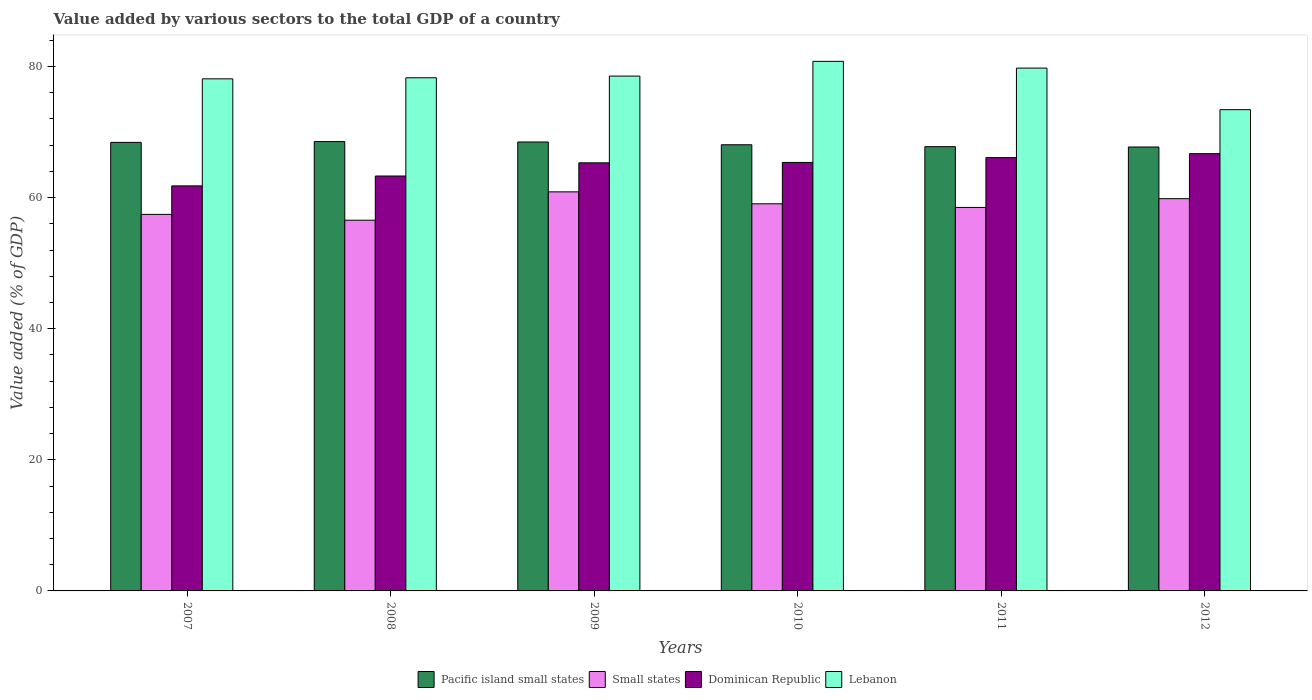Are the number of bars on each tick of the X-axis equal?
Offer a terse response. Yes. How many bars are there on the 4th tick from the left?
Give a very brief answer. 4. In how many cases, is the number of bars for a given year not equal to the number of legend labels?
Offer a very short reply. 0. What is the value added by various sectors to the total GDP in Lebanon in 2007?
Your answer should be compact. 78.11. Across all years, what is the maximum value added by various sectors to the total GDP in Small states?
Provide a succinct answer. 60.87. Across all years, what is the minimum value added by various sectors to the total GDP in Lebanon?
Offer a very short reply. 73.41. In which year was the value added by various sectors to the total GDP in Lebanon maximum?
Make the answer very short. 2010. What is the total value added by various sectors to the total GDP in Small states in the graph?
Provide a short and direct response. 352.22. What is the difference between the value added by various sectors to the total GDP in Dominican Republic in 2011 and that in 2012?
Your response must be concise. -0.6. What is the difference between the value added by various sectors to the total GDP in Pacific island small states in 2008 and the value added by various sectors to the total GDP in Lebanon in 2009?
Offer a very short reply. -9.99. What is the average value added by various sectors to the total GDP in Dominican Republic per year?
Ensure brevity in your answer.  64.75. In the year 2011, what is the difference between the value added by various sectors to the total GDP in Pacific island small states and value added by various sectors to the total GDP in Lebanon?
Ensure brevity in your answer.  -11.99. What is the ratio of the value added by various sectors to the total GDP in Small states in 2007 to that in 2011?
Provide a succinct answer. 0.98. Is the value added by various sectors to the total GDP in Lebanon in 2007 less than that in 2008?
Keep it short and to the point. Yes. What is the difference between the highest and the second highest value added by various sectors to the total GDP in Small states?
Keep it short and to the point. 1.04. What is the difference between the highest and the lowest value added by various sectors to the total GDP in Lebanon?
Offer a very short reply. 7.37. In how many years, is the value added by various sectors to the total GDP in Small states greater than the average value added by various sectors to the total GDP in Small states taken over all years?
Offer a terse response. 3. What does the 4th bar from the left in 2011 represents?
Ensure brevity in your answer.  Lebanon. What does the 1st bar from the right in 2007 represents?
Your answer should be very brief. Lebanon. Is it the case that in every year, the sum of the value added by various sectors to the total GDP in Small states and value added by various sectors to the total GDP in Lebanon is greater than the value added by various sectors to the total GDP in Pacific island small states?
Give a very brief answer. Yes. How many years are there in the graph?
Provide a short and direct response. 6. Are the values on the major ticks of Y-axis written in scientific E-notation?
Provide a succinct answer. No. Where does the legend appear in the graph?
Your response must be concise. Bottom center. How are the legend labels stacked?
Provide a short and direct response. Horizontal. What is the title of the graph?
Offer a terse response. Value added by various sectors to the total GDP of a country. Does "Grenada" appear as one of the legend labels in the graph?
Ensure brevity in your answer.  No. What is the label or title of the X-axis?
Ensure brevity in your answer.  Years. What is the label or title of the Y-axis?
Provide a short and direct response. Value added (% of GDP). What is the Value added (% of GDP) in Pacific island small states in 2007?
Offer a very short reply. 68.42. What is the Value added (% of GDP) of Small states in 2007?
Offer a terse response. 57.43. What is the Value added (% of GDP) of Dominican Republic in 2007?
Offer a terse response. 61.78. What is the Value added (% of GDP) of Lebanon in 2007?
Offer a terse response. 78.11. What is the Value added (% of GDP) in Pacific island small states in 2008?
Offer a terse response. 68.54. What is the Value added (% of GDP) in Small states in 2008?
Your answer should be compact. 56.54. What is the Value added (% of GDP) of Dominican Republic in 2008?
Give a very brief answer. 63.29. What is the Value added (% of GDP) in Lebanon in 2008?
Provide a succinct answer. 78.27. What is the Value added (% of GDP) in Pacific island small states in 2009?
Ensure brevity in your answer.  68.48. What is the Value added (% of GDP) of Small states in 2009?
Give a very brief answer. 60.87. What is the Value added (% of GDP) of Dominican Republic in 2009?
Your response must be concise. 65.3. What is the Value added (% of GDP) of Lebanon in 2009?
Your answer should be very brief. 78.53. What is the Value added (% of GDP) in Pacific island small states in 2010?
Keep it short and to the point. 68.05. What is the Value added (% of GDP) in Small states in 2010?
Provide a short and direct response. 59.05. What is the Value added (% of GDP) of Dominican Republic in 2010?
Ensure brevity in your answer.  65.36. What is the Value added (% of GDP) in Lebanon in 2010?
Give a very brief answer. 80.78. What is the Value added (% of GDP) in Pacific island small states in 2011?
Provide a succinct answer. 67.76. What is the Value added (% of GDP) in Small states in 2011?
Offer a terse response. 58.49. What is the Value added (% of GDP) of Dominican Republic in 2011?
Your answer should be very brief. 66.09. What is the Value added (% of GDP) of Lebanon in 2011?
Provide a succinct answer. 79.75. What is the Value added (% of GDP) in Pacific island small states in 2012?
Your answer should be compact. 67.71. What is the Value added (% of GDP) in Small states in 2012?
Provide a succinct answer. 59.83. What is the Value added (% of GDP) in Dominican Republic in 2012?
Your answer should be compact. 66.7. What is the Value added (% of GDP) of Lebanon in 2012?
Your answer should be compact. 73.41. Across all years, what is the maximum Value added (% of GDP) of Pacific island small states?
Offer a very short reply. 68.54. Across all years, what is the maximum Value added (% of GDP) in Small states?
Your answer should be compact. 60.87. Across all years, what is the maximum Value added (% of GDP) of Dominican Republic?
Keep it short and to the point. 66.7. Across all years, what is the maximum Value added (% of GDP) in Lebanon?
Offer a very short reply. 80.78. Across all years, what is the minimum Value added (% of GDP) of Pacific island small states?
Your answer should be compact. 67.71. Across all years, what is the minimum Value added (% of GDP) of Small states?
Your answer should be compact. 56.54. Across all years, what is the minimum Value added (% of GDP) of Dominican Republic?
Keep it short and to the point. 61.78. Across all years, what is the minimum Value added (% of GDP) of Lebanon?
Keep it short and to the point. 73.41. What is the total Value added (% of GDP) in Pacific island small states in the graph?
Provide a succinct answer. 408.96. What is the total Value added (% of GDP) in Small states in the graph?
Provide a succinct answer. 352.22. What is the total Value added (% of GDP) of Dominican Republic in the graph?
Offer a very short reply. 388.51. What is the total Value added (% of GDP) in Lebanon in the graph?
Your answer should be very brief. 468.84. What is the difference between the Value added (% of GDP) of Pacific island small states in 2007 and that in 2008?
Make the answer very short. -0.12. What is the difference between the Value added (% of GDP) in Small states in 2007 and that in 2008?
Keep it short and to the point. 0.89. What is the difference between the Value added (% of GDP) in Dominican Republic in 2007 and that in 2008?
Offer a very short reply. -1.5. What is the difference between the Value added (% of GDP) of Lebanon in 2007 and that in 2008?
Offer a terse response. -0.16. What is the difference between the Value added (% of GDP) of Pacific island small states in 2007 and that in 2009?
Your response must be concise. -0.06. What is the difference between the Value added (% of GDP) of Small states in 2007 and that in 2009?
Offer a very short reply. -3.44. What is the difference between the Value added (% of GDP) in Dominican Republic in 2007 and that in 2009?
Provide a short and direct response. -3.52. What is the difference between the Value added (% of GDP) of Lebanon in 2007 and that in 2009?
Ensure brevity in your answer.  -0.42. What is the difference between the Value added (% of GDP) of Pacific island small states in 2007 and that in 2010?
Your answer should be very brief. 0.36. What is the difference between the Value added (% of GDP) of Small states in 2007 and that in 2010?
Keep it short and to the point. -1.61. What is the difference between the Value added (% of GDP) in Dominican Republic in 2007 and that in 2010?
Offer a very short reply. -3.58. What is the difference between the Value added (% of GDP) in Lebanon in 2007 and that in 2010?
Ensure brevity in your answer.  -2.66. What is the difference between the Value added (% of GDP) of Pacific island small states in 2007 and that in 2011?
Offer a very short reply. 0.65. What is the difference between the Value added (% of GDP) of Small states in 2007 and that in 2011?
Your answer should be very brief. -1.06. What is the difference between the Value added (% of GDP) of Dominican Republic in 2007 and that in 2011?
Offer a terse response. -4.31. What is the difference between the Value added (% of GDP) of Lebanon in 2007 and that in 2011?
Your response must be concise. -1.64. What is the difference between the Value added (% of GDP) of Pacific island small states in 2007 and that in 2012?
Offer a terse response. 0.7. What is the difference between the Value added (% of GDP) in Small states in 2007 and that in 2012?
Your answer should be very brief. -2.4. What is the difference between the Value added (% of GDP) of Dominican Republic in 2007 and that in 2012?
Your response must be concise. -4.91. What is the difference between the Value added (% of GDP) of Lebanon in 2007 and that in 2012?
Give a very brief answer. 4.71. What is the difference between the Value added (% of GDP) in Pacific island small states in 2008 and that in 2009?
Provide a short and direct response. 0.06. What is the difference between the Value added (% of GDP) of Small states in 2008 and that in 2009?
Give a very brief answer. -4.33. What is the difference between the Value added (% of GDP) in Dominican Republic in 2008 and that in 2009?
Give a very brief answer. -2.01. What is the difference between the Value added (% of GDP) in Lebanon in 2008 and that in 2009?
Your answer should be compact. -0.26. What is the difference between the Value added (% of GDP) in Pacific island small states in 2008 and that in 2010?
Keep it short and to the point. 0.49. What is the difference between the Value added (% of GDP) of Small states in 2008 and that in 2010?
Provide a short and direct response. -2.5. What is the difference between the Value added (% of GDP) in Dominican Republic in 2008 and that in 2010?
Your answer should be very brief. -2.07. What is the difference between the Value added (% of GDP) in Lebanon in 2008 and that in 2010?
Provide a short and direct response. -2.51. What is the difference between the Value added (% of GDP) of Pacific island small states in 2008 and that in 2011?
Your response must be concise. 0.78. What is the difference between the Value added (% of GDP) in Small states in 2008 and that in 2011?
Provide a short and direct response. -1.95. What is the difference between the Value added (% of GDP) of Dominican Republic in 2008 and that in 2011?
Keep it short and to the point. -2.81. What is the difference between the Value added (% of GDP) in Lebanon in 2008 and that in 2011?
Give a very brief answer. -1.48. What is the difference between the Value added (% of GDP) of Pacific island small states in 2008 and that in 2012?
Your answer should be very brief. 0.83. What is the difference between the Value added (% of GDP) in Small states in 2008 and that in 2012?
Ensure brevity in your answer.  -3.29. What is the difference between the Value added (% of GDP) of Dominican Republic in 2008 and that in 2012?
Ensure brevity in your answer.  -3.41. What is the difference between the Value added (% of GDP) of Lebanon in 2008 and that in 2012?
Give a very brief answer. 4.86. What is the difference between the Value added (% of GDP) of Pacific island small states in 2009 and that in 2010?
Offer a very short reply. 0.42. What is the difference between the Value added (% of GDP) in Small states in 2009 and that in 2010?
Your response must be concise. 1.82. What is the difference between the Value added (% of GDP) in Dominican Republic in 2009 and that in 2010?
Your answer should be compact. -0.06. What is the difference between the Value added (% of GDP) of Lebanon in 2009 and that in 2010?
Ensure brevity in your answer.  -2.25. What is the difference between the Value added (% of GDP) of Pacific island small states in 2009 and that in 2011?
Provide a succinct answer. 0.72. What is the difference between the Value added (% of GDP) in Small states in 2009 and that in 2011?
Your answer should be compact. 2.38. What is the difference between the Value added (% of GDP) in Dominican Republic in 2009 and that in 2011?
Give a very brief answer. -0.79. What is the difference between the Value added (% of GDP) of Lebanon in 2009 and that in 2011?
Offer a very short reply. -1.22. What is the difference between the Value added (% of GDP) of Pacific island small states in 2009 and that in 2012?
Offer a very short reply. 0.76. What is the difference between the Value added (% of GDP) of Small states in 2009 and that in 2012?
Provide a succinct answer. 1.04. What is the difference between the Value added (% of GDP) in Dominican Republic in 2009 and that in 2012?
Your answer should be compact. -1.4. What is the difference between the Value added (% of GDP) in Lebanon in 2009 and that in 2012?
Your answer should be compact. 5.12. What is the difference between the Value added (% of GDP) in Pacific island small states in 2010 and that in 2011?
Your answer should be compact. 0.29. What is the difference between the Value added (% of GDP) of Small states in 2010 and that in 2011?
Keep it short and to the point. 0.55. What is the difference between the Value added (% of GDP) of Dominican Republic in 2010 and that in 2011?
Your answer should be very brief. -0.73. What is the difference between the Value added (% of GDP) of Lebanon in 2010 and that in 2011?
Ensure brevity in your answer.  1.03. What is the difference between the Value added (% of GDP) of Pacific island small states in 2010 and that in 2012?
Ensure brevity in your answer.  0.34. What is the difference between the Value added (% of GDP) of Small states in 2010 and that in 2012?
Provide a succinct answer. -0.78. What is the difference between the Value added (% of GDP) of Dominican Republic in 2010 and that in 2012?
Your answer should be compact. -1.34. What is the difference between the Value added (% of GDP) in Lebanon in 2010 and that in 2012?
Your answer should be compact. 7.37. What is the difference between the Value added (% of GDP) of Pacific island small states in 2011 and that in 2012?
Make the answer very short. 0.05. What is the difference between the Value added (% of GDP) in Small states in 2011 and that in 2012?
Offer a terse response. -1.34. What is the difference between the Value added (% of GDP) of Dominican Republic in 2011 and that in 2012?
Your answer should be very brief. -0.6. What is the difference between the Value added (% of GDP) of Lebanon in 2011 and that in 2012?
Ensure brevity in your answer.  6.34. What is the difference between the Value added (% of GDP) in Pacific island small states in 2007 and the Value added (% of GDP) in Small states in 2008?
Give a very brief answer. 11.87. What is the difference between the Value added (% of GDP) of Pacific island small states in 2007 and the Value added (% of GDP) of Dominican Republic in 2008?
Make the answer very short. 5.13. What is the difference between the Value added (% of GDP) of Pacific island small states in 2007 and the Value added (% of GDP) of Lebanon in 2008?
Your answer should be very brief. -9.85. What is the difference between the Value added (% of GDP) of Small states in 2007 and the Value added (% of GDP) of Dominican Republic in 2008?
Your answer should be compact. -5.85. What is the difference between the Value added (% of GDP) in Small states in 2007 and the Value added (% of GDP) in Lebanon in 2008?
Your answer should be compact. -20.84. What is the difference between the Value added (% of GDP) of Dominican Republic in 2007 and the Value added (% of GDP) of Lebanon in 2008?
Give a very brief answer. -16.49. What is the difference between the Value added (% of GDP) of Pacific island small states in 2007 and the Value added (% of GDP) of Small states in 2009?
Your response must be concise. 7.55. What is the difference between the Value added (% of GDP) of Pacific island small states in 2007 and the Value added (% of GDP) of Dominican Republic in 2009?
Offer a very short reply. 3.12. What is the difference between the Value added (% of GDP) in Pacific island small states in 2007 and the Value added (% of GDP) in Lebanon in 2009?
Your answer should be very brief. -10.11. What is the difference between the Value added (% of GDP) in Small states in 2007 and the Value added (% of GDP) in Dominican Republic in 2009?
Keep it short and to the point. -7.86. What is the difference between the Value added (% of GDP) of Small states in 2007 and the Value added (% of GDP) of Lebanon in 2009?
Your response must be concise. -21.1. What is the difference between the Value added (% of GDP) of Dominican Republic in 2007 and the Value added (% of GDP) of Lebanon in 2009?
Your answer should be compact. -16.75. What is the difference between the Value added (% of GDP) in Pacific island small states in 2007 and the Value added (% of GDP) in Small states in 2010?
Make the answer very short. 9.37. What is the difference between the Value added (% of GDP) in Pacific island small states in 2007 and the Value added (% of GDP) in Dominican Republic in 2010?
Offer a very short reply. 3.06. What is the difference between the Value added (% of GDP) of Pacific island small states in 2007 and the Value added (% of GDP) of Lebanon in 2010?
Offer a very short reply. -12.36. What is the difference between the Value added (% of GDP) of Small states in 2007 and the Value added (% of GDP) of Dominican Republic in 2010?
Keep it short and to the point. -7.92. What is the difference between the Value added (% of GDP) in Small states in 2007 and the Value added (% of GDP) in Lebanon in 2010?
Your answer should be very brief. -23.34. What is the difference between the Value added (% of GDP) of Dominican Republic in 2007 and the Value added (% of GDP) of Lebanon in 2010?
Keep it short and to the point. -18.99. What is the difference between the Value added (% of GDP) in Pacific island small states in 2007 and the Value added (% of GDP) in Small states in 2011?
Provide a short and direct response. 9.92. What is the difference between the Value added (% of GDP) in Pacific island small states in 2007 and the Value added (% of GDP) in Dominican Republic in 2011?
Provide a short and direct response. 2.32. What is the difference between the Value added (% of GDP) in Pacific island small states in 2007 and the Value added (% of GDP) in Lebanon in 2011?
Your answer should be compact. -11.33. What is the difference between the Value added (% of GDP) of Small states in 2007 and the Value added (% of GDP) of Dominican Republic in 2011?
Make the answer very short. -8.66. What is the difference between the Value added (% of GDP) in Small states in 2007 and the Value added (% of GDP) in Lebanon in 2011?
Offer a terse response. -22.32. What is the difference between the Value added (% of GDP) of Dominican Republic in 2007 and the Value added (% of GDP) of Lebanon in 2011?
Your answer should be very brief. -17.97. What is the difference between the Value added (% of GDP) of Pacific island small states in 2007 and the Value added (% of GDP) of Small states in 2012?
Provide a succinct answer. 8.59. What is the difference between the Value added (% of GDP) in Pacific island small states in 2007 and the Value added (% of GDP) in Dominican Republic in 2012?
Your answer should be very brief. 1.72. What is the difference between the Value added (% of GDP) in Pacific island small states in 2007 and the Value added (% of GDP) in Lebanon in 2012?
Make the answer very short. -4.99. What is the difference between the Value added (% of GDP) in Small states in 2007 and the Value added (% of GDP) in Dominican Republic in 2012?
Keep it short and to the point. -9.26. What is the difference between the Value added (% of GDP) in Small states in 2007 and the Value added (% of GDP) in Lebanon in 2012?
Your answer should be very brief. -15.97. What is the difference between the Value added (% of GDP) of Dominican Republic in 2007 and the Value added (% of GDP) of Lebanon in 2012?
Your answer should be very brief. -11.62. What is the difference between the Value added (% of GDP) in Pacific island small states in 2008 and the Value added (% of GDP) in Small states in 2009?
Your answer should be very brief. 7.67. What is the difference between the Value added (% of GDP) of Pacific island small states in 2008 and the Value added (% of GDP) of Dominican Republic in 2009?
Your response must be concise. 3.24. What is the difference between the Value added (% of GDP) of Pacific island small states in 2008 and the Value added (% of GDP) of Lebanon in 2009?
Keep it short and to the point. -9.99. What is the difference between the Value added (% of GDP) of Small states in 2008 and the Value added (% of GDP) of Dominican Republic in 2009?
Provide a succinct answer. -8.75. What is the difference between the Value added (% of GDP) of Small states in 2008 and the Value added (% of GDP) of Lebanon in 2009?
Keep it short and to the point. -21.99. What is the difference between the Value added (% of GDP) in Dominican Republic in 2008 and the Value added (% of GDP) in Lebanon in 2009?
Keep it short and to the point. -15.24. What is the difference between the Value added (% of GDP) in Pacific island small states in 2008 and the Value added (% of GDP) in Small states in 2010?
Keep it short and to the point. 9.49. What is the difference between the Value added (% of GDP) of Pacific island small states in 2008 and the Value added (% of GDP) of Dominican Republic in 2010?
Your answer should be compact. 3.18. What is the difference between the Value added (% of GDP) of Pacific island small states in 2008 and the Value added (% of GDP) of Lebanon in 2010?
Give a very brief answer. -12.24. What is the difference between the Value added (% of GDP) in Small states in 2008 and the Value added (% of GDP) in Dominican Republic in 2010?
Keep it short and to the point. -8.81. What is the difference between the Value added (% of GDP) of Small states in 2008 and the Value added (% of GDP) of Lebanon in 2010?
Provide a short and direct response. -24.23. What is the difference between the Value added (% of GDP) of Dominican Republic in 2008 and the Value added (% of GDP) of Lebanon in 2010?
Give a very brief answer. -17.49. What is the difference between the Value added (% of GDP) in Pacific island small states in 2008 and the Value added (% of GDP) in Small states in 2011?
Keep it short and to the point. 10.04. What is the difference between the Value added (% of GDP) in Pacific island small states in 2008 and the Value added (% of GDP) in Dominican Republic in 2011?
Offer a terse response. 2.45. What is the difference between the Value added (% of GDP) in Pacific island small states in 2008 and the Value added (% of GDP) in Lebanon in 2011?
Your response must be concise. -11.21. What is the difference between the Value added (% of GDP) of Small states in 2008 and the Value added (% of GDP) of Dominican Republic in 2011?
Provide a short and direct response. -9.55. What is the difference between the Value added (% of GDP) in Small states in 2008 and the Value added (% of GDP) in Lebanon in 2011?
Give a very brief answer. -23.21. What is the difference between the Value added (% of GDP) in Dominican Republic in 2008 and the Value added (% of GDP) in Lebanon in 2011?
Keep it short and to the point. -16.46. What is the difference between the Value added (% of GDP) of Pacific island small states in 2008 and the Value added (% of GDP) of Small states in 2012?
Make the answer very short. 8.71. What is the difference between the Value added (% of GDP) of Pacific island small states in 2008 and the Value added (% of GDP) of Dominican Republic in 2012?
Provide a succinct answer. 1.84. What is the difference between the Value added (% of GDP) in Pacific island small states in 2008 and the Value added (% of GDP) in Lebanon in 2012?
Your response must be concise. -4.87. What is the difference between the Value added (% of GDP) in Small states in 2008 and the Value added (% of GDP) in Dominican Republic in 2012?
Your answer should be compact. -10.15. What is the difference between the Value added (% of GDP) of Small states in 2008 and the Value added (% of GDP) of Lebanon in 2012?
Make the answer very short. -16.86. What is the difference between the Value added (% of GDP) of Dominican Republic in 2008 and the Value added (% of GDP) of Lebanon in 2012?
Keep it short and to the point. -10.12. What is the difference between the Value added (% of GDP) in Pacific island small states in 2009 and the Value added (% of GDP) in Small states in 2010?
Offer a very short reply. 9.43. What is the difference between the Value added (% of GDP) in Pacific island small states in 2009 and the Value added (% of GDP) in Dominican Republic in 2010?
Provide a succinct answer. 3.12. What is the difference between the Value added (% of GDP) in Pacific island small states in 2009 and the Value added (% of GDP) in Lebanon in 2010?
Keep it short and to the point. -12.3. What is the difference between the Value added (% of GDP) of Small states in 2009 and the Value added (% of GDP) of Dominican Republic in 2010?
Provide a succinct answer. -4.49. What is the difference between the Value added (% of GDP) of Small states in 2009 and the Value added (% of GDP) of Lebanon in 2010?
Keep it short and to the point. -19.91. What is the difference between the Value added (% of GDP) in Dominican Republic in 2009 and the Value added (% of GDP) in Lebanon in 2010?
Give a very brief answer. -15.48. What is the difference between the Value added (% of GDP) in Pacific island small states in 2009 and the Value added (% of GDP) in Small states in 2011?
Ensure brevity in your answer.  9.98. What is the difference between the Value added (% of GDP) in Pacific island small states in 2009 and the Value added (% of GDP) in Dominican Republic in 2011?
Keep it short and to the point. 2.39. What is the difference between the Value added (% of GDP) of Pacific island small states in 2009 and the Value added (% of GDP) of Lebanon in 2011?
Ensure brevity in your answer.  -11.27. What is the difference between the Value added (% of GDP) of Small states in 2009 and the Value added (% of GDP) of Dominican Republic in 2011?
Offer a very short reply. -5.22. What is the difference between the Value added (% of GDP) in Small states in 2009 and the Value added (% of GDP) in Lebanon in 2011?
Offer a terse response. -18.88. What is the difference between the Value added (% of GDP) of Dominican Republic in 2009 and the Value added (% of GDP) of Lebanon in 2011?
Give a very brief answer. -14.45. What is the difference between the Value added (% of GDP) in Pacific island small states in 2009 and the Value added (% of GDP) in Small states in 2012?
Offer a terse response. 8.65. What is the difference between the Value added (% of GDP) of Pacific island small states in 2009 and the Value added (% of GDP) of Dominican Republic in 2012?
Make the answer very short. 1.78. What is the difference between the Value added (% of GDP) of Pacific island small states in 2009 and the Value added (% of GDP) of Lebanon in 2012?
Offer a terse response. -4.93. What is the difference between the Value added (% of GDP) of Small states in 2009 and the Value added (% of GDP) of Dominican Republic in 2012?
Offer a terse response. -5.83. What is the difference between the Value added (% of GDP) in Small states in 2009 and the Value added (% of GDP) in Lebanon in 2012?
Your answer should be compact. -12.54. What is the difference between the Value added (% of GDP) of Dominican Republic in 2009 and the Value added (% of GDP) of Lebanon in 2012?
Provide a short and direct response. -8.11. What is the difference between the Value added (% of GDP) in Pacific island small states in 2010 and the Value added (% of GDP) in Small states in 2011?
Offer a very short reply. 9.56. What is the difference between the Value added (% of GDP) of Pacific island small states in 2010 and the Value added (% of GDP) of Dominican Republic in 2011?
Provide a succinct answer. 1.96. What is the difference between the Value added (% of GDP) in Pacific island small states in 2010 and the Value added (% of GDP) in Lebanon in 2011?
Provide a succinct answer. -11.7. What is the difference between the Value added (% of GDP) of Small states in 2010 and the Value added (% of GDP) of Dominican Republic in 2011?
Give a very brief answer. -7.05. What is the difference between the Value added (% of GDP) in Small states in 2010 and the Value added (% of GDP) in Lebanon in 2011?
Offer a terse response. -20.7. What is the difference between the Value added (% of GDP) in Dominican Republic in 2010 and the Value added (% of GDP) in Lebanon in 2011?
Your answer should be compact. -14.39. What is the difference between the Value added (% of GDP) of Pacific island small states in 2010 and the Value added (% of GDP) of Small states in 2012?
Your answer should be very brief. 8.22. What is the difference between the Value added (% of GDP) of Pacific island small states in 2010 and the Value added (% of GDP) of Dominican Republic in 2012?
Keep it short and to the point. 1.36. What is the difference between the Value added (% of GDP) of Pacific island small states in 2010 and the Value added (% of GDP) of Lebanon in 2012?
Give a very brief answer. -5.35. What is the difference between the Value added (% of GDP) in Small states in 2010 and the Value added (% of GDP) in Dominican Republic in 2012?
Provide a succinct answer. -7.65. What is the difference between the Value added (% of GDP) of Small states in 2010 and the Value added (% of GDP) of Lebanon in 2012?
Offer a terse response. -14.36. What is the difference between the Value added (% of GDP) of Dominican Republic in 2010 and the Value added (% of GDP) of Lebanon in 2012?
Your answer should be very brief. -8.05. What is the difference between the Value added (% of GDP) of Pacific island small states in 2011 and the Value added (% of GDP) of Small states in 2012?
Provide a succinct answer. 7.93. What is the difference between the Value added (% of GDP) of Pacific island small states in 2011 and the Value added (% of GDP) of Dominican Republic in 2012?
Make the answer very short. 1.07. What is the difference between the Value added (% of GDP) in Pacific island small states in 2011 and the Value added (% of GDP) in Lebanon in 2012?
Make the answer very short. -5.64. What is the difference between the Value added (% of GDP) in Small states in 2011 and the Value added (% of GDP) in Dominican Republic in 2012?
Provide a short and direct response. -8.2. What is the difference between the Value added (% of GDP) in Small states in 2011 and the Value added (% of GDP) in Lebanon in 2012?
Offer a very short reply. -14.91. What is the difference between the Value added (% of GDP) in Dominican Republic in 2011 and the Value added (% of GDP) in Lebanon in 2012?
Provide a succinct answer. -7.31. What is the average Value added (% of GDP) of Pacific island small states per year?
Make the answer very short. 68.16. What is the average Value added (% of GDP) of Small states per year?
Provide a short and direct response. 58.7. What is the average Value added (% of GDP) in Dominican Republic per year?
Offer a very short reply. 64.75. What is the average Value added (% of GDP) of Lebanon per year?
Provide a succinct answer. 78.14. In the year 2007, what is the difference between the Value added (% of GDP) of Pacific island small states and Value added (% of GDP) of Small states?
Make the answer very short. 10.98. In the year 2007, what is the difference between the Value added (% of GDP) in Pacific island small states and Value added (% of GDP) in Dominican Republic?
Provide a short and direct response. 6.64. In the year 2007, what is the difference between the Value added (% of GDP) in Pacific island small states and Value added (% of GDP) in Lebanon?
Make the answer very short. -9.69. In the year 2007, what is the difference between the Value added (% of GDP) of Small states and Value added (% of GDP) of Dominican Republic?
Make the answer very short. -4.35. In the year 2007, what is the difference between the Value added (% of GDP) of Small states and Value added (% of GDP) of Lebanon?
Your answer should be compact. -20.68. In the year 2007, what is the difference between the Value added (% of GDP) of Dominican Republic and Value added (% of GDP) of Lebanon?
Provide a succinct answer. -16.33. In the year 2008, what is the difference between the Value added (% of GDP) in Pacific island small states and Value added (% of GDP) in Small states?
Your answer should be compact. 12. In the year 2008, what is the difference between the Value added (% of GDP) of Pacific island small states and Value added (% of GDP) of Dominican Republic?
Provide a short and direct response. 5.25. In the year 2008, what is the difference between the Value added (% of GDP) of Pacific island small states and Value added (% of GDP) of Lebanon?
Offer a terse response. -9.73. In the year 2008, what is the difference between the Value added (% of GDP) in Small states and Value added (% of GDP) in Dominican Republic?
Ensure brevity in your answer.  -6.74. In the year 2008, what is the difference between the Value added (% of GDP) of Small states and Value added (% of GDP) of Lebanon?
Your answer should be very brief. -21.73. In the year 2008, what is the difference between the Value added (% of GDP) in Dominican Republic and Value added (% of GDP) in Lebanon?
Offer a very short reply. -14.98. In the year 2009, what is the difference between the Value added (% of GDP) of Pacific island small states and Value added (% of GDP) of Small states?
Your response must be concise. 7.61. In the year 2009, what is the difference between the Value added (% of GDP) of Pacific island small states and Value added (% of GDP) of Dominican Republic?
Make the answer very short. 3.18. In the year 2009, what is the difference between the Value added (% of GDP) in Pacific island small states and Value added (% of GDP) in Lebanon?
Give a very brief answer. -10.05. In the year 2009, what is the difference between the Value added (% of GDP) of Small states and Value added (% of GDP) of Dominican Republic?
Give a very brief answer. -4.43. In the year 2009, what is the difference between the Value added (% of GDP) of Small states and Value added (% of GDP) of Lebanon?
Make the answer very short. -17.66. In the year 2009, what is the difference between the Value added (% of GDP) in Dominican Republic and Value added (% of GDP) in Lebanon?
Offer a terse response. -13.23. In the year 2010, what is the difference between the Value added (% of GDP) of Pacific island small states and Value added (% of GDP) of Small states?
Provide a succinct answer. 9.01. In the year 2010, what is the difference between the Value added (% of GDP) in Pacific island small states and Value added (% of GDP) in Dominican Republic?
Offer a terse response. 2.7. In the year 2010, what is the difference between the Value added (% of GDP) of Pacific island small states and Value added (% of GDP) of Lebanon?
Offer a terse response. -12.72. In the year 2010, what is the difference between the Value added (% of GDP) in Small states and Value added (% of GDP) in Dominican Republic?
Give a very brief answer. -6.31. In the year 2010, what is the difference between the Value added (% of GDP) in Small states and Value added (% of GDP) in Lebanon?
Give a very brief answer. -21.73. In the year 2010, what is the difference between the Value added (% of GDP) of Dominican Republic and Value added (% of GDP) of Lebanon?
Ensure brevity in your answer.  -15.42. In the year 2011, what is the difference between the Value added (% of GDP) of Pacific island small states and Value added (% of GDP) of Small states?
Provide a succinct answer. 9.27. In the year 2011, what is the difference between the Value added (% of GDP) in Pacific island small states and Value added (% of GDP) in Dominican Republic?
Keep it short and to the point. 1.67. In the year 2011, what is the difference between the Value added (% of GDP) in Pacific island small states and Value added (% of GDP) in Lebanon?
Keep it short and to the point. -11.99. In the year 2011, what is the difference between the Value added (% of GDP) in Small states and Value added (% of GDP) in Dominican Republic?
Provide a short and direct response. -7.6. In the year 2011, what is the difference between the Value added (% of GDP) of Small states and Value added (% of GDP) of Lebanon?
Give a very brief answer. -21.25. In the year 2011, what is the difference between the Value added (% of GDP) in Dominican Republic and Value added (% of GDP) in Lebanon?
Keep it short and to the point. -13.66. In the year 2012, what is the difference between the Value added (% of GDP) in Pacific island small states and Value added (% of GDP) in Small states?
Keep it short and to the point. 7.88. In the year 2012, what is the difference between the Value added (% of GDP) of Pacific island small states and Value added (% of GDP) of Dominican Republic?
Your answer should be compact. 1.02. In the year 2012, what is the difference between the Value added (% of GDP) in Pacific island small states and Value added (% of GDP) in Lebanon?
Offer a terse response. -5.69. In the year 2012, what is the difference between the Value added (% of GDP) of Small states and Value added (% of GDP) of Dominican Republic?
Ensure brevity in your answer.  -6.87. In the year 2012, what is the difference between the Value added (% of GDP) of Small states and Value added (% of GDP) of Lebanon?
Ensure brevity in your answer.  -13.57. In the year 2012, what is the difference between the Value added (% of GDP) of Dominican Republic and Value added (% of GDP) of Lebanon?
Offer a very short reply. -6.71. What is the ratio of the Value added (% of GDP) in Small states in 2007 to that in 2008?
Provide a short and direct response. 1.02. What is the ratio of the Value added (% of GDP) in Dominican Republic in 2007 to that in 2008?
Your answer should be very brief. 0.98. What is the ratio of the Value added (% of GDP) in Lebanon in 2007 to that in 2008?
Your answer should be compact. 1. What is the ratio of the Value added (% of GDP) in Small states in 2007 to that in 2009?
Your response must be concise. 0.94. What is the ratio of the Value added (% of GDP) in Dominican Republic in 2007 to that in 2009?
Provide a succinct answer. 0.95. What is the ratio of the Value added (% of GDP) of Pacific island small states in 2007 to that in 2010?
Ensure brevity in your answer.  1.01. What is the ratio of the Value added (% of GDP) of Small states in 2007 to that in 2010?
Offer a very short reply. 0.97. What is the ratio of the Value added (% of GDP) of Dominican Republic in 2007 to that in 2010?
Give a very brief answer. 0.95. What is the ratio of the Value added (% of GDP) of Pacific island small states in 2007 to that in 2011?
Make the answer very short. 1.01. What is the ratio of the Value added (% of GDP) in Small states in 2007 to that in 2011?
Your response must be concise. 0.98. What is the ratio of the Value added (% of GDP) in Dominican Republic in 2007 to that in 2011?
Your answer should be very brief. 0.93. What is the ratio of the Value added (% of GDP) in Lebanon in 2007 to that in 2011?
Offer a very short reply. 0.98. What is the ratio of the Value added (% of GDP) of Pacific island small states in 2007 to that in 2012?
Make the answer very short. 1.01. What is the ratio of the Value added (% of GDP) in Small states in 2007 to that in 2012?
Make the answer very short. 0.96. What is the ratio of the Value added (% of GDP) of Dominican Republic in 2007 to that in 2012?
Provide a short and direct response. 0.93. What is the ratio of the Value added (% of GDP) in Lebanon in 2007 to that in 2012?
Ensure brevity in your answer.  1.06. What is the ratio of the Value added (% of GDP) in Pacific island small states in 2008 to that in 2009?
Your answer should be compact. 1. What is the ratio of the Value added (% of GDP) in Small states in 2008 to that in 2009?
Provide a succinct answer. 0.93. What is the ratio of the Value added (% of GDP) in Dominican Republic in 2008 to that in 2009?
Your response must be concise. 0.97. What is the ratio of the Value added (% of GDP) in Lebanon in 2008 to that in 2009?
Provide a short and direct response. 1. What is the ratio of the Value added (% of GDP) in Pacific island small states in 2008 to that in 2010?
Give a very brief answer. 1.01. What is the ratio of the Value added (% of GDP) of Small states in 2008 to that in 2010?
Offer a terse response. 0.96. What is the ratio of the Value added (% of GDP) of Dominican Republic in 2008 to that in 2010?
Your answer should be very brief. 0.97. What is the ratio of the Value added (% of GDP) of Lebanon in 2008 to that in 2010?
Your answer should be compact. 0.97. What is the ratio of the Value added (% of GDP) in Pacific island small states in 2008 to that in 2011?
Your answer should be very brief. 1.01. What is the ratio of the Value added (% of GDP) of Small states in 2008 to that in 2011?
Provide a succinct answer. 0.97. What is the ratio of the Value added (% of GDP) in Dominican Republic in 2008 to that in 2011?
Give a very brief answer. 0.96. What is the ratio of the Value added (% of GDP) in Lebanon in 2008 to that in 2011?
Your response must be concise. 0.98. What is the ratio of the Value added (% of GDP) in Pacific island small states in 2008 to that in 2012?
Make the answer very short. 1.01. What is the ratio of the Value added (% of GDP) in Small states in 2008 to that in 2012?
Provide a short and direct response. 0.95. What is the ratio of the Value added (% of GDP) in Dominican Republic in 2008 to that in 2012?
Provide a succinct answer. 0.95. What is the ratio of the Value added (% of GDP) in Lebanon in 2008 to that in 2012?
Offer a terse response. 1.07. What is the ratio of the Value added (% of GDP) in Small states in 2009 to that in 2010?
Make the answer very short. 1.03. What is the ratio of the Value added (% of GDP) of Lebanon in 2009 to that in 2010?
Make the answer very short. 0.97. What is the ratio of the Value added (% of GDP) of Pacific island small states in 2009 to that in 2011?
Give a very brief answer. 1.01. What is the ratio of the Value added (% of GDP) in Small states in 2009 to that in 2011?
Your answer should be very brief. 1.04. What is the ratio of the Value added (% of GDP) in Lebanon in 2009 to that in 2011?
Provide a succinct answer. 0.98. What is the ratio of the Value added (% of GDP) of Pacific island small states in 2009 to that in 2012?
Make the answer very short. 1.01. What is the ratio of the Value added (% of GDP) of Small states in 2009 to that in 2012?
Your answer should be compact. 1.02. What is the ratio of the Value added (% of GDP) of Lebanon in 2009 to that in 2012?
Provide a short and direct response. 1.07. What is the ratio of the Value added (% of GDP) in Small states in 2010 to that in 2011?
Keep it short and to the point. 1.01. What is the ratio of the Value added (% of GDP) in Dominican Republic in 2010 to that in 2011?
Your answer should be compact. 0.99. What is the ratio of the Value added (% of GDP) of Lebanon in 2010 to that in 2011?
Keep it short and to the point. 1.01. What is the ratio of the Value added (% of GDP) in Pacific island small states in 2010 to that in 2012?
Provide a succinct answer. 1. What is the ratio of the Value added (% of GDP) in Small states in 2010 to that in 2012?
Keep it short and to the point. 0.99. What is the ratio of the Value added (% of GDP) in Dominican Republic in 2010 to that in 2012?
Offer a terse response. 0.98. What is the ratio of the Value added (% of GDP) of Lebanon in 2010 to that in 2012?
Give a very brief answer. 1.1. What is the ratio of the Value added (% of GDP) of Small states in 2011 to that in 2012?
Give a very brief answer. 0.98. What is the ratio of the Value added (% of GDP) in Dominican Republic in 2011 to that in 2012?
Provide a short and direct response. 0.99. What is the ratio of the Value added (% of GDP) of Lebanon in 2011 to that in 2012?
Offer a terse response. 1.09. What is the difference between the highest and the second highest Value added (% of GDP) in Pacific island small states?
Offer a very short reply. 0.06. What is the difference between the highest and the second highest Value added (% of GDP) of Small states?
Offer a terse response. 1.04. What is the difference between the highest and the second highest Value added (% of GDP) of Dominican Republic?
Provide a succinct answer. 0.6. What is the difference between the highest and the second highest Value added (% of GDP) of Lebanon?
Provide a succinct answer. 1.03. What is the difference between the highest and the lowest Value added (% of GDP) in Pacific island small states?
Make the answer very short. 0.83. What is the difference between the highest and the lowest Value added (% of GDP) of Small states?
Provide a succinct answer. 4.33. What is the difference between the highest and the lowest Value added (% of GDP) in Dominican Republic?
Give a very brief answer. 4.91. What is the difference between the highest and the lowest Value added (% of GDP) in Lebanon?
Offer a terse response. 7.37. 